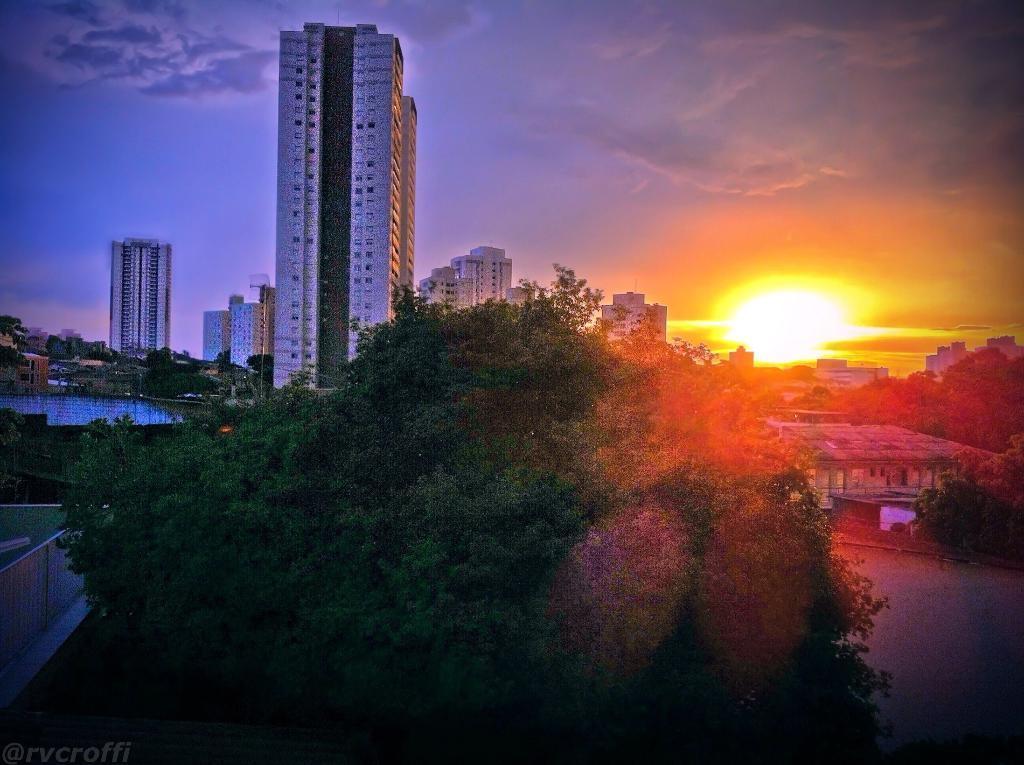How would you summarize this image in a sentence or two? In this image there are trees, buildings and a lake, in the background of the image there are clouds and sun in the sky. 